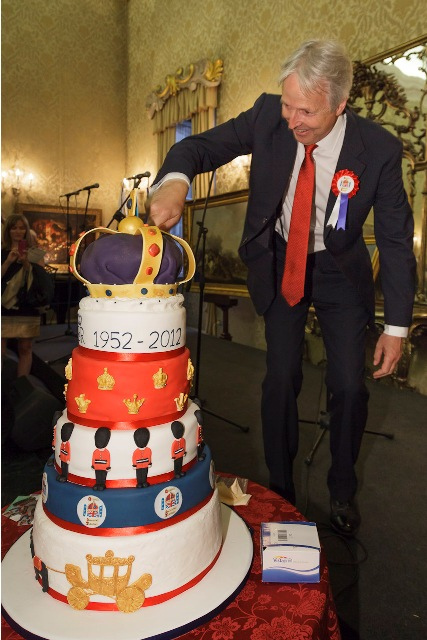Please identify all text content in this image. 1952 2012 